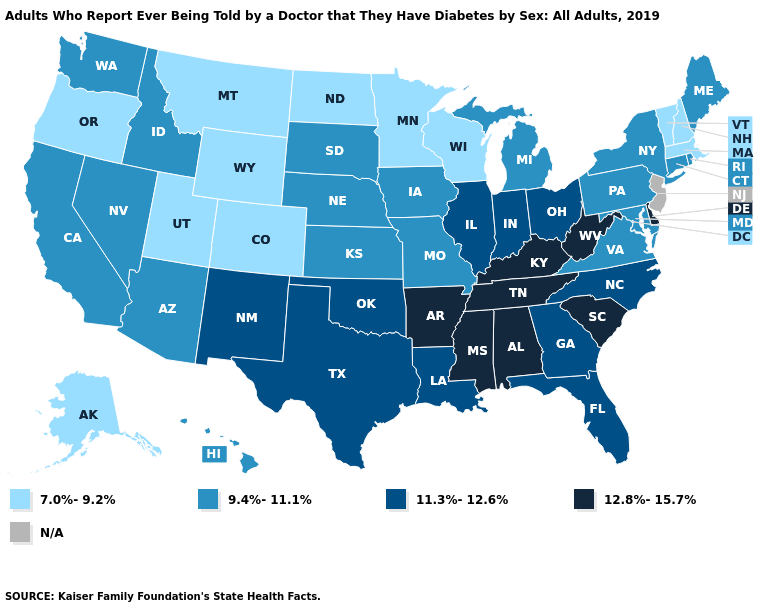Does Kentucky have the highest value in the South?
Keep it brief. Yes. Name the states that have a value in the range 9.4%-11.1%?
Concise answer only. Arizona, California, Connecticut, Hawaii, Idaho, Iowa, Kansas, Maine, Maryland, Michigan, Missouri, Nebraska, Nevada, New York, Pennsylvania, Rhode Island, South Dakota, Virginia, Washington. What is the highest value in the USA?
Short answer required. 12.8%-15.7%. Name the states that have a value in the range N/A?
Give a very brief answer. New Jersey. What is the highest value in states that border Montana?
Answer briefly. 9.4%-11.1%. What is the lowest value in the MidWest?
Write a very short answer. 7.0%-9.2%. Name the states that have a value in the range 12.8%-15.7%?
Quick response, please. Alabama, Arkansas, Delaware, Kentucky, Mississippi, South Carolina, Tennessee, West Virginia. Name the states that have a value in the range 9.4%-11.1%?
Be succinct. Arizona, California, Connecticut, Hawaii, Idaho, Iowa, Kansas, Maine, Maryland, Michigan, Missouri, Nebraska, Nevada, New York, Pennsylvania, Rhode Island, South Dakota, Virginia, Washington. Does the map have missing data?
Short answer required. Yes. Among the states that border Minnesota , does Iowa have the highest value?
Answer briefly. Yes. Name the states that have a value in the range 12.8%-15.7%?
Write a very short answer. Alabama, Arkansas, Delaware, Kentucky, Mississippi, South Carolina, Tennessee, West Virginia. Name the states that have a value in the range 7.0%-9.2%?
Concise answer only. Alaska, Colorado, Massachusetts, Minnesota, Montana, New Hampshire, North Dakota, Oregon, Utah, Vermont, Wisconsin, Wyoming. Among the states that border Michigan , which have the lowest value?
Answer briefly. Wisconsin. What is the value of Vermont?
Concise answer only. 7.0%-9.2%. Among the states that border Rhode Island , does Massachusetts have the highest value?
Short answer required. No. 